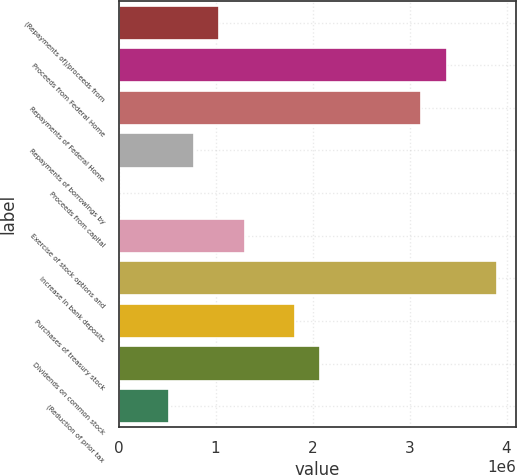Convert chart. <chart><loc_0><loc_0><loc_500><loc_500><bar_chart><fcel>(Repayments of)/proceeds from<fcel>Proceeds from Federal Home<fcel>Repayments of Federal Home<fcel>Repayments of borrowings by<fcel>Proceeds from capital<fcel>Exercise of stock options and<fcel>Increase in bank deposits<fcel>Purchases of treasury stock<fcel>Dividends on common stock<fcel>(Reduction of prior tax<nl><fcel>1.04047e+06<fcel>3.38127e+06<fcel>3.12119e+06<fcel>780379<fcel>110<fcel>1.30056e+06<fcel>3.90145e+06<fcel>1.82074e+06<fcel>2.08083e+06<fcel>520289<nl></chart> 